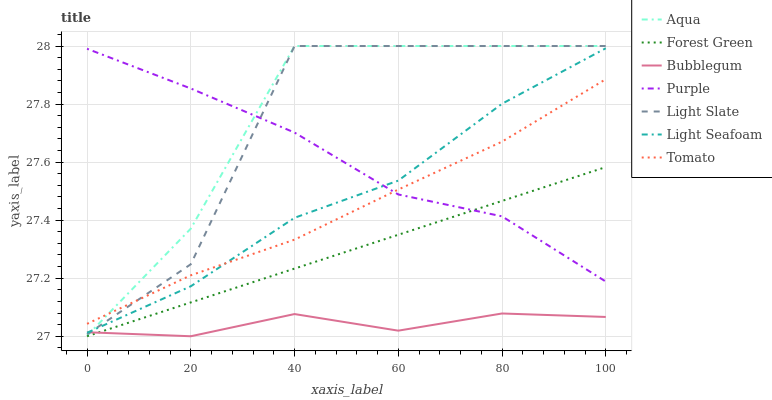Does Bubblegum have the minimum area under the curve?
Answer yes or no. Yes. Does Aqua have the maximum area under the curve?
Answer yes or no. Yes. Does Purple have the minimum area under the curve?
Answer yes or no. No. Does Purple have the maximum area under the curve?
Answer yes or no. No. Is Forest Green the smoothest?
Answer yes or no. Yes. Is Light Slate the roughest?
Answer yes or no. Yes. Is Purple the smoothest?
Answer yes or no. No. Is Purple the roughest?
Answer yes or no. No. Does Aqua have the lowest value?
Answer yes or no. No. Does Light Slate have the highest value?
Answer yes or no. Yes. Does Purple have the highest value?
Answer yes or no. No. Is Forest Green less than Light Seafoam?
Answer yes or no. Yes. Is Light Slate greater than Forest Green?
Answer yes or no. Yes. Does Tomato intersect Aqua?
Answer yes or no. Yes. Is Tomato less than Aqua?
Answer yes or no. No. Is Tomato greater than Aqua?
Answer yes or no. No. Does Forest Green intersect Light Seafoam?
Answer yes or no. No. 